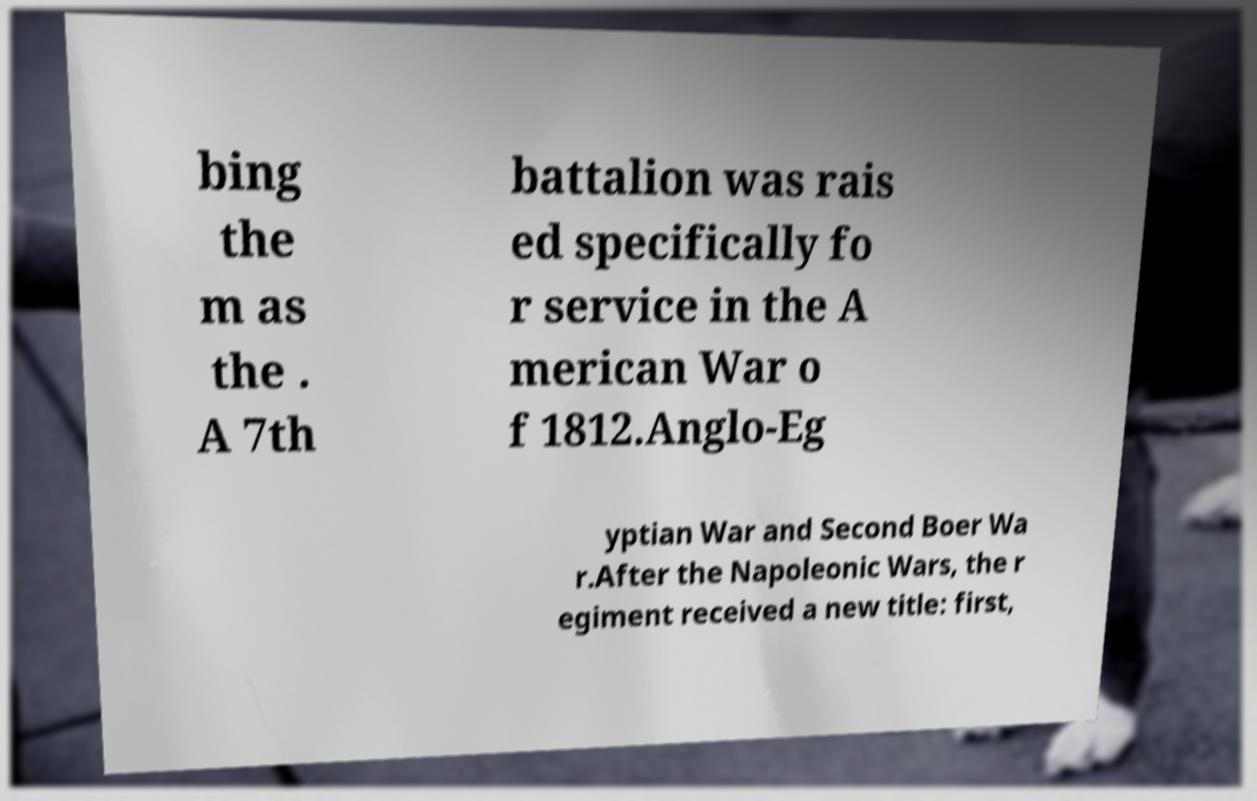Please read and relay the text visible in this image. What does it say? bing the m as the . A 7th battalion was rais ed specifically fo r service in the A merican War o f 1812.Anglo-Eg yptian War and Second Boer Wa r.After the Napoleonic Wars, the r egiment received a new title: first, 